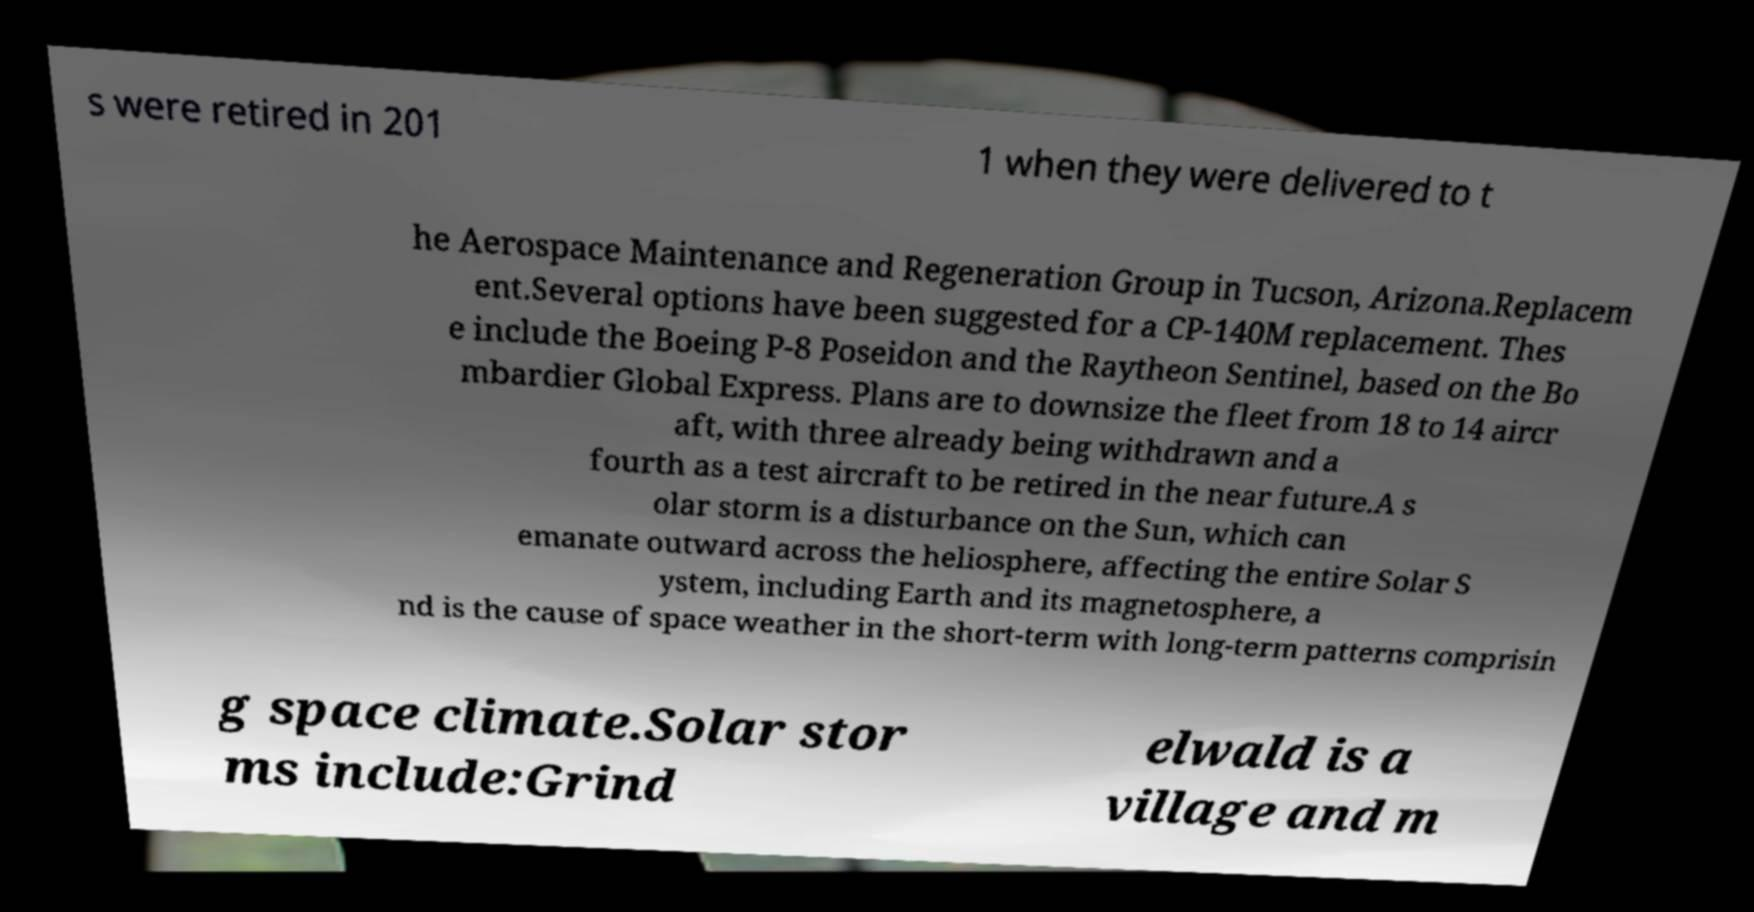There's text embedded in this image that I need extracted. Can you transcribe it verbatim? s were retired in 201 1 when they were delivered to t he Aerospace Maintenance and Regeneration Group in Tucson, Arizona.Replacem ent.Several options have been suggested for a CP-140M replacement. Thes e include the Boeing P-8 Poseidon and the Raytheon Sentinel, based on the Bo mbardier Global Express. Plans are to downsize the fleet from 18 to 14 aircr aft, with three already being withdrawn and a fourth as a test aircraft to be retired in the near future.A s olar storm is a disturbance on the Sun, which can emanate outward across the heliosphere, affecting the entire Solar S ystem, including Earth and its magnetosphere, a nd is the cause of space weather in the short-term with long-term patterns comprisin g space climate.Solar stor ms include:Grind elwald is a village and m 